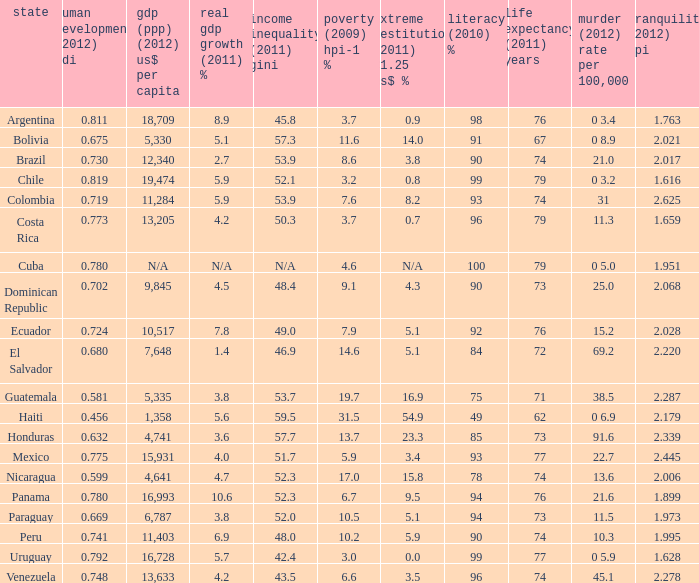What is the sum of poverty (2009) HPI-1 % when the GDP (PPP) (2012) US$ per capita of 11,284? 1.0. 